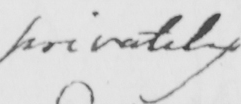Can you tell me what this handwritten text says? privately 